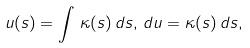Convert formula to latex. <formula><loc_0><loc_0><loc_500><loc_500>u ( s ) = \int \, \kappa ( s ) \, d s , \, d u = \kappa ( s ) \, d s ,</formula> 